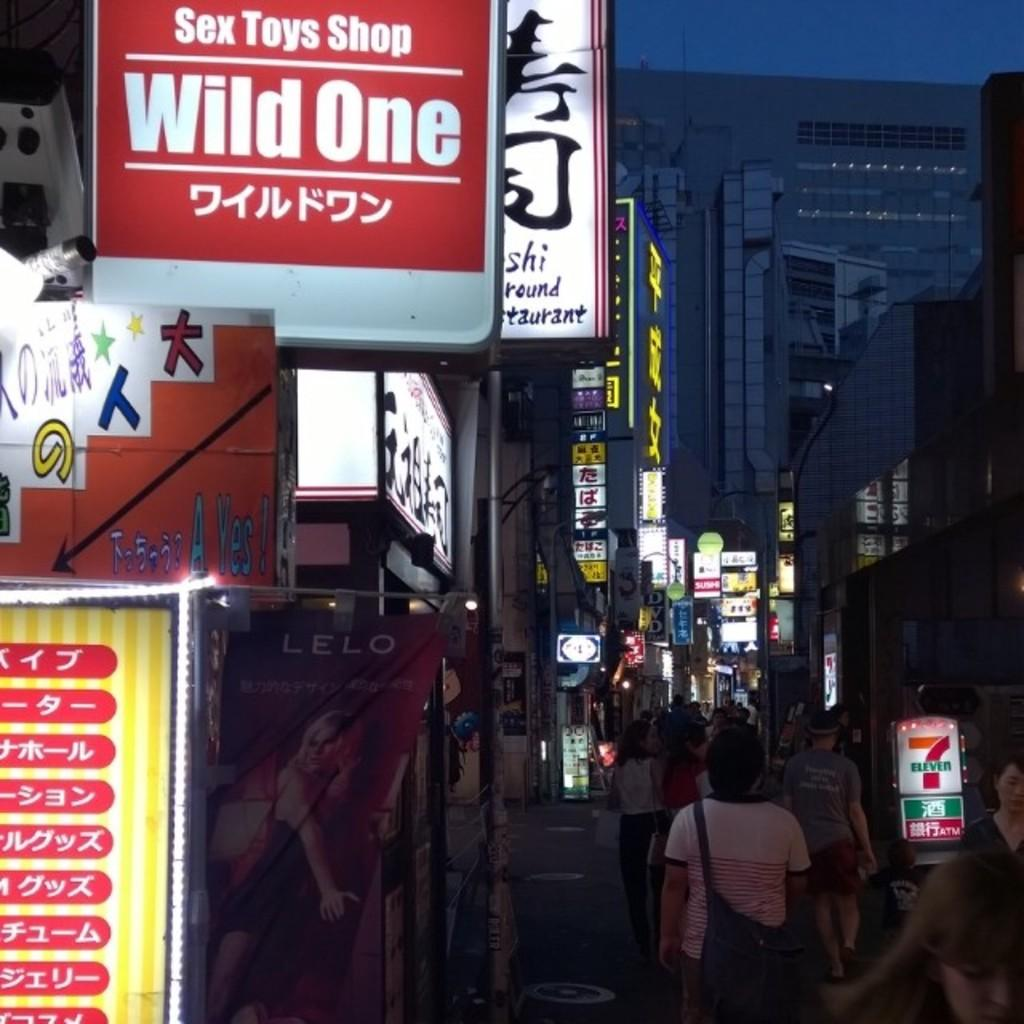<image>
Write a terse but informative summary of the picture. A row of many businesses with light up signs one says Sex Toys Shop Wild One on it with words in a foreign language under it. 